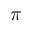<formula> <loc_0><loc_0><loc_500><loc_500>\pi</formula> 